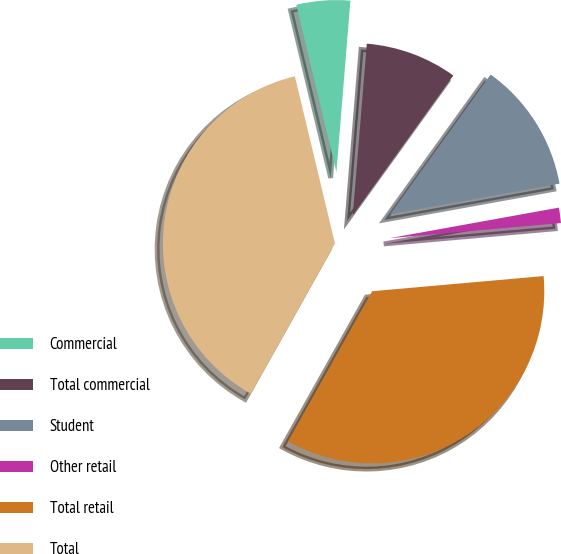Convert chart. <chart><loc_0><loc_0><loc_500><loc_500><pie_chart><fcel>Commercial<fcel>Total commercial<fcel>Student<fcel>Other retail<fcel>Total retail<fcel>Total<nl><fcel>5.04%<fcel>8.63%<fcel>12.23%<fcel>1.44%<fcel>34.53%<fcel>38.13%<nl></chart> 